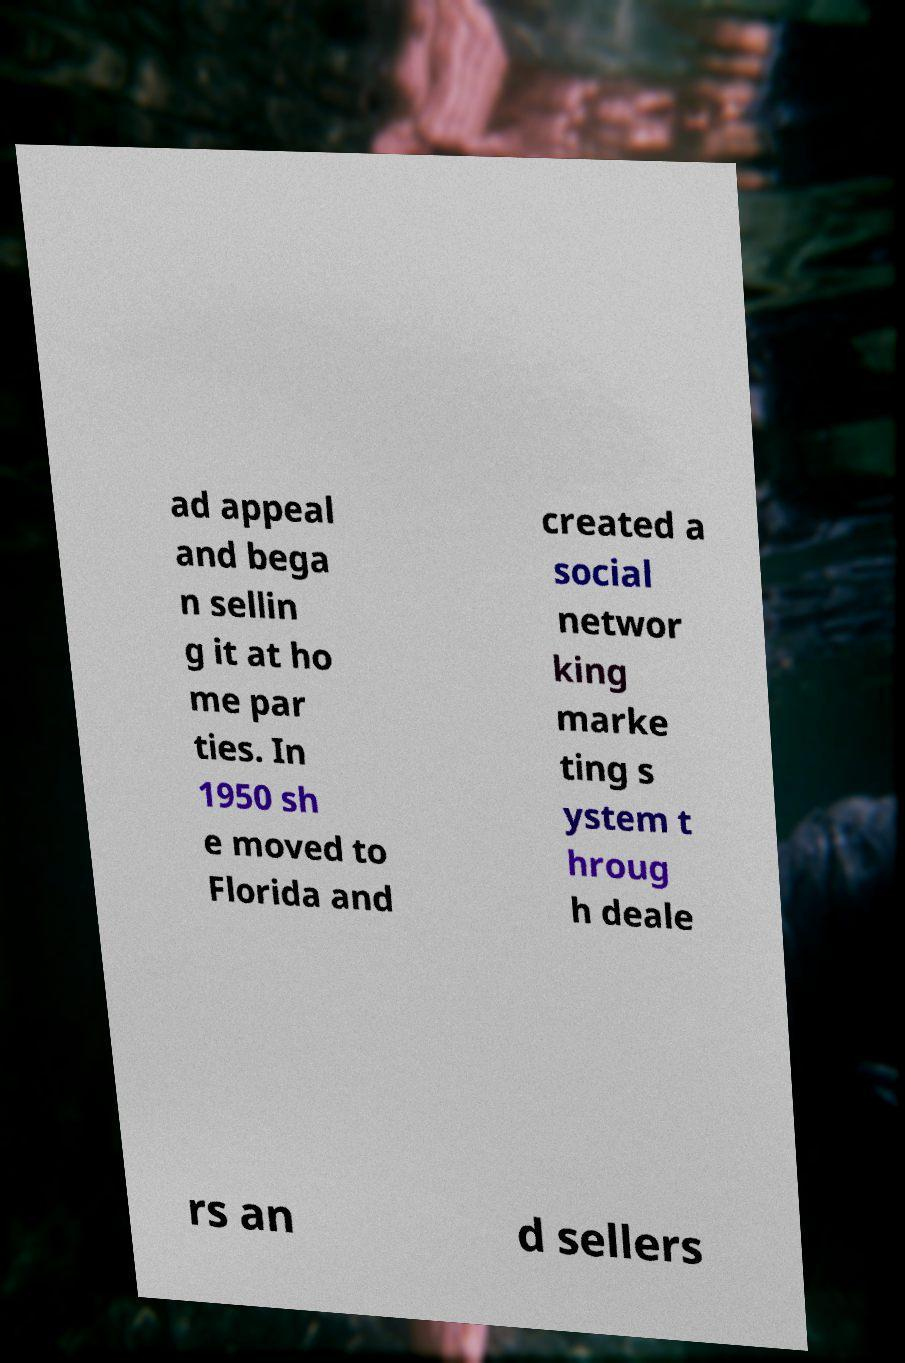Please read and relay the text visible in this image. What does it say? ad appeal and bega n sellin g it at ho me par ties. In 1950 sh e moved to Florida and created a social networ king marke ting s ystem t hroug h deale rs an d sellers 